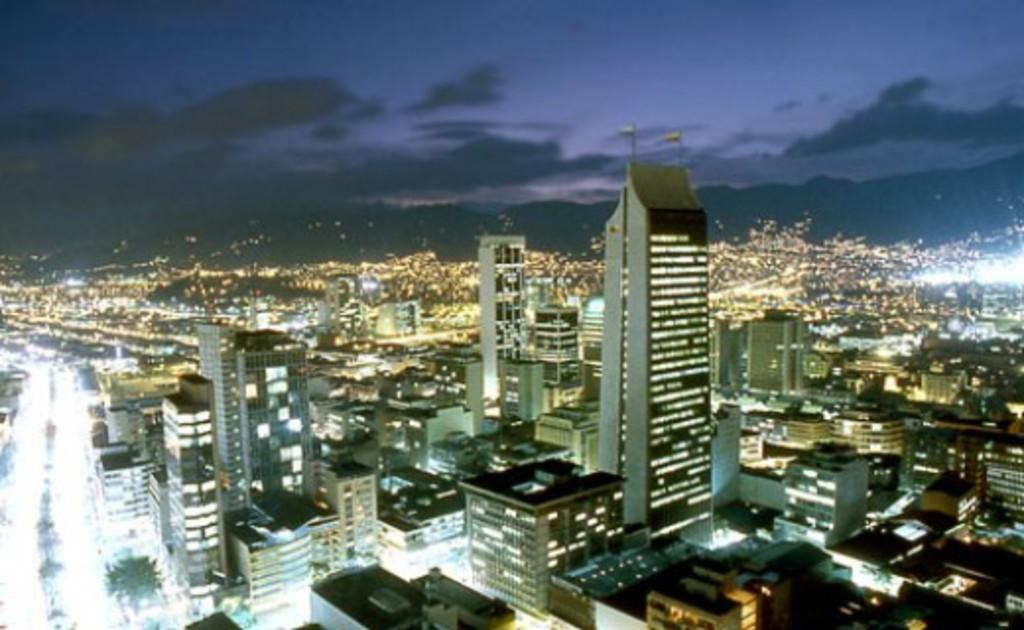What type of structures can be seen in the image? There are buildings in the image. What is located on the left side of the image? There is a road with lights on the left side of the image. What is visible at the top of the image? The sky is visible at the top of the image. What can be observed in the sky? There are clouds in the sky. What type of beef is being served in the room depicted in the image? There is no room or beef present in the image; it features buildings, a road with lights, and a sky with clouds. 